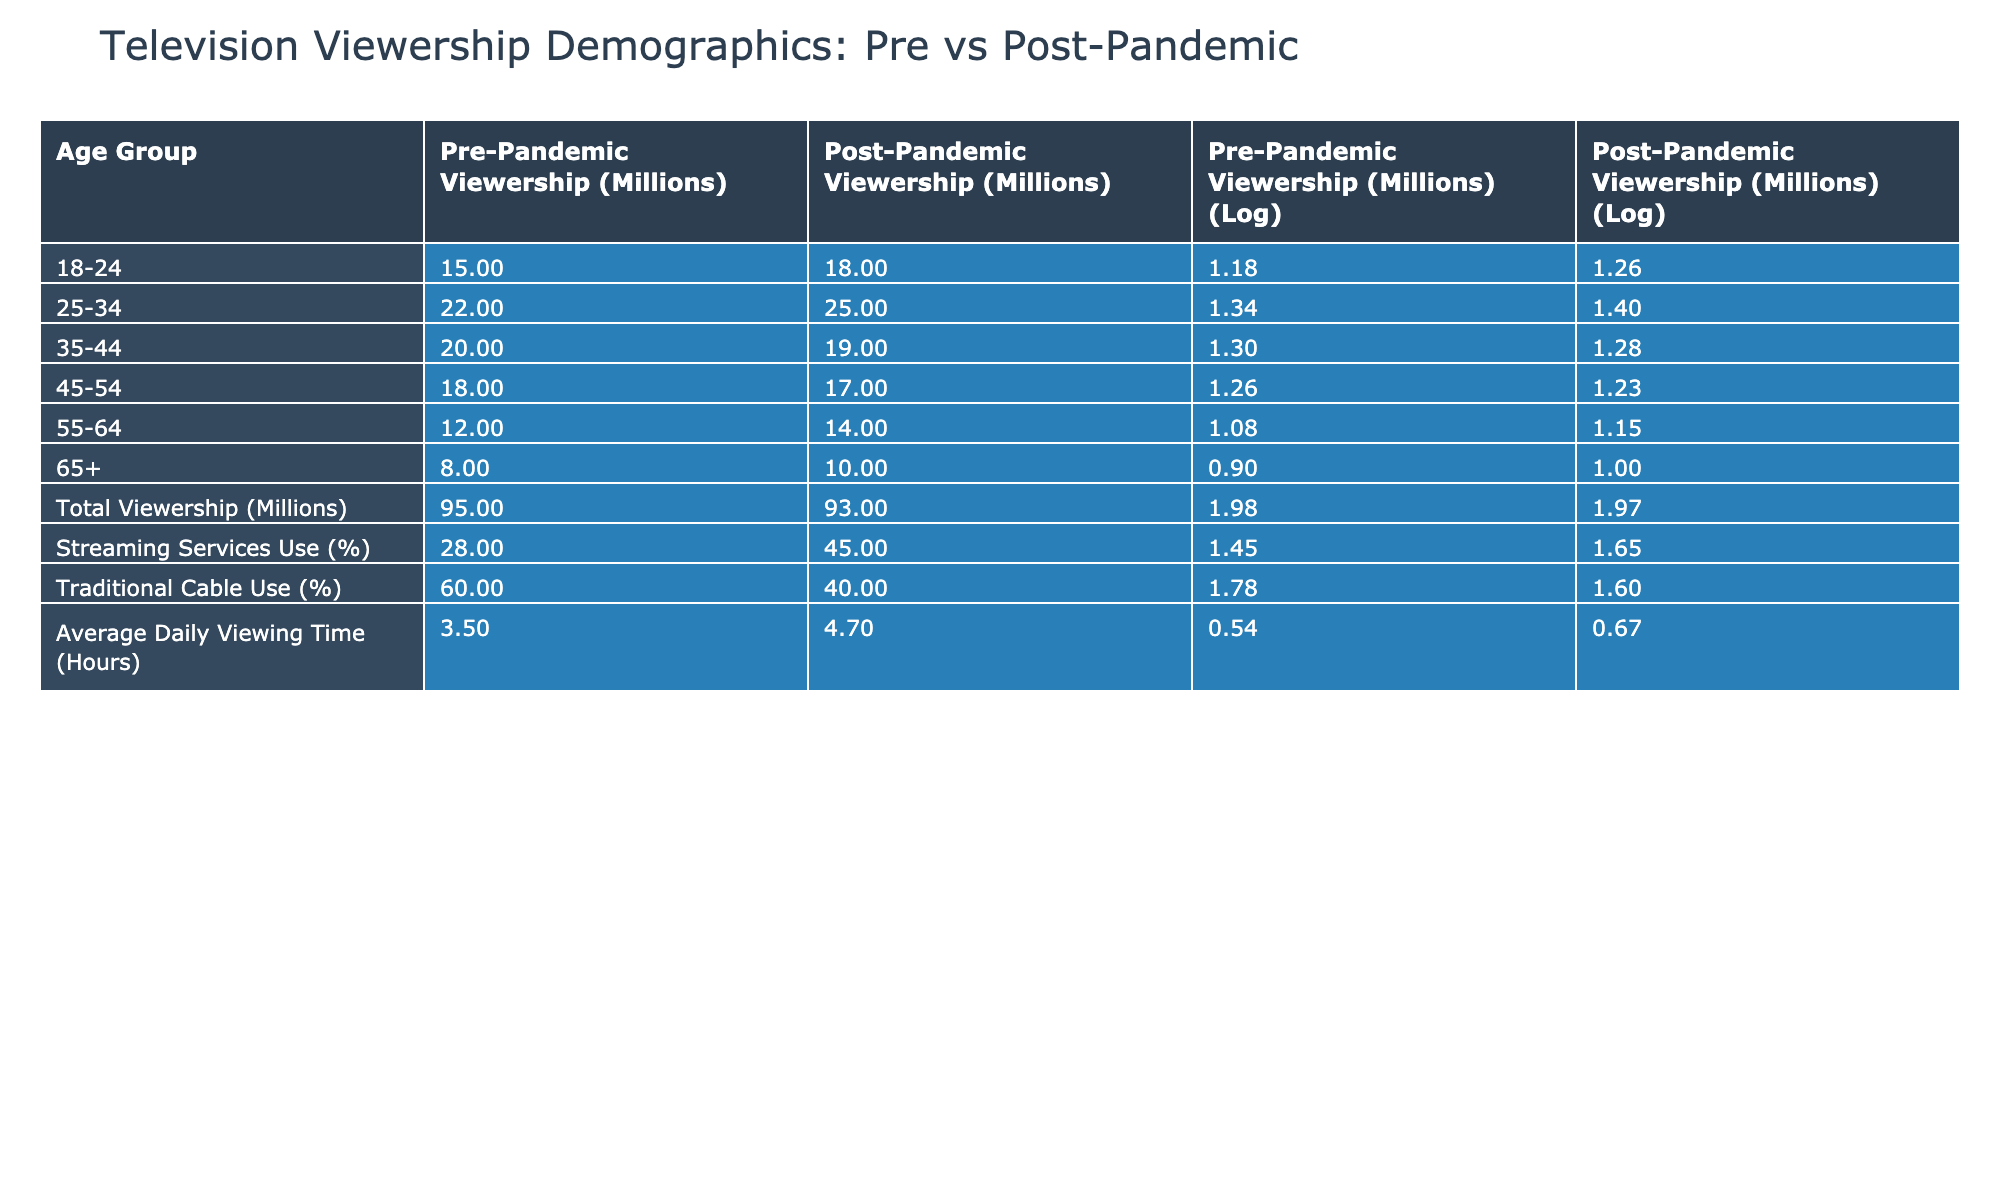What was the total pre-pandemic viewership? The total pre-pandemic viewership, according to the table, is the sum of the viewership of all age groups before the pandemic. Adding: 15 + 22 + 20 + 18 + 12 + 8 gives a total of 95 million.
Answer: 95 million Which age group saw an increase in viewership post-pandemic? From the table, the age groups that experienced an increase in viewership are 18-24 (from 15 to 18 million) and 55-64 (from 12 to 14 million). These two groups have higher post-pandemic numbers compared to their pre-pandemic figures.
Answer: 18-24 and 55-64 Is the average daily viewing time higher post-pandemic? The table shows that the average daily viewing time increased from 3.5 hours pre-pandemic to 4.7 hours post-pandemic, which indicates that yes, the average daily viewing time is higher post-pandemic.
Answer: Yes What is the difference in traditional cable use percentage pre- and post-pandemic? The pre-pandemic traditional cable use was 60%, and it decreased to 40% post-pandemic. The difference can be calculated as 60 - 40 = 20%. Thus, there is a 20% decrease in traditional cable use.
Answer: 20% Which age group had the highest pre-pandemic viewership? Looking at the pre-pandemic viewership figures for each age group, the 25-34 age group had the highest number at 22 million. This is the largest figure in the pre-pandemic column across all age groups.
Answer: 25-34 What was the increase in streaming service use percentage post-pandemic? The percentage of streaming service use increased from 28% to 45% post-pandemic. To find the increase, we subtract: 45 - 28 = 17%. Thus, there was a 17% increase in streaming service use.
Answer: 17% Did the total viewership decline post-pandemic? Total viewership decreased from 95 million pre-pandemic to 93 million post-pandemic, indicating that yes, the total viewership did decline.
Answer: Yes What is the average viewership for age group 35-44 both pre- and post-pandemic? Pre-pandemic viewership for the age group 35-44 was 20 million, and post-pandemic it was 19 million. The average can be calculated as (20 + 19) / 2 = 19.5 million. Hence, the average is 19.5 million.
Answer: 19.5 million How many age groups experienced a decline in viewership post-pandemic? The age groups that experienced a decline in viewership post-pandemic are 35-44 (from 20 million to 19 million), 45-54 (from 18 million to 17 million), and 25-34 (from 22 million to 25 million). Thus, three age groups saw a decline.
Answer: 3 